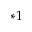<formula> <loc_0><loc_0><loc_500><loc_500>^ { * 1 }</formula> 